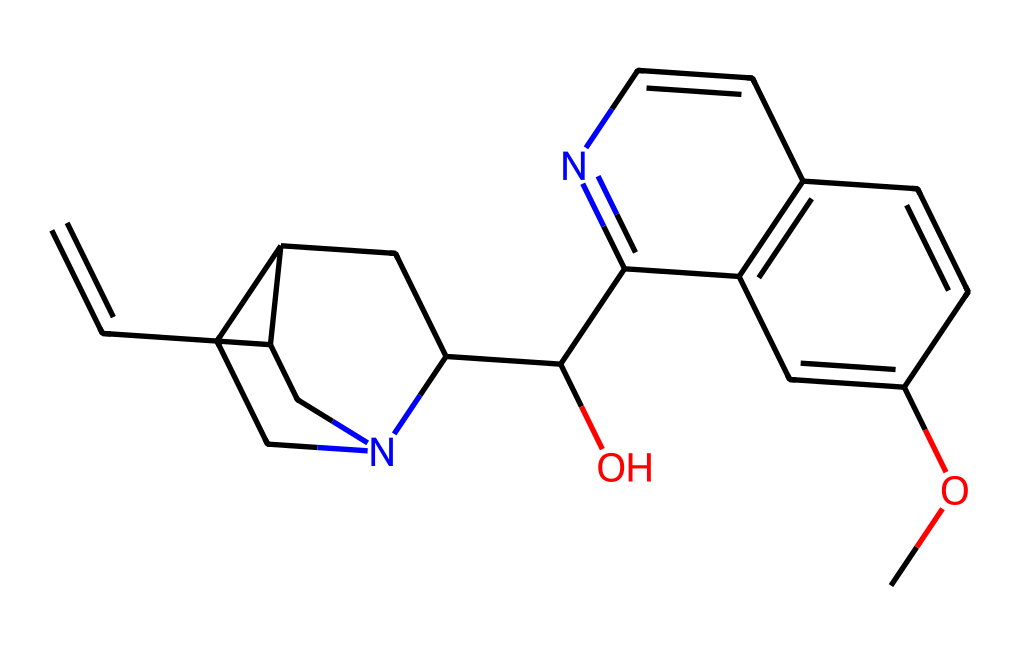What is the chemical name of the structure represented by the SMILES? The SMILES representation corresponds to quinine, which is a well-known antimalarial alkaloid. The specific arrangement of atoms and bonds indicates that it is quinine.
Answer: quinine How many nitrogen atoms are present in this structure? By examining the SMILES representation, we identify and count the nitrogen atoms, which appear to be two in total.
Answer: two What functional group is represented within this alkaloid? The chemical structure includes an ether functional group, as indicated by the "-O-" or oxygen atom connected to carbon chains.
Answer: ether What type of carbon chain is primarily found in quinine? An analysis of the structure reveals that quinine contains multiple fused cyclohexane rings, which are typical of its organic structure.
Answer: fused cyclohexane rings How does the arrangement of atoms contribute to the bioactivity of quinine? The specific arrangement and presence of functional groups like the nitrogen atoms create a shape that fits certain biological targets, leading to its antimalarial properties. The diverse ring structure and functional groups enhance its interaction with biological systems.
Answer: it enhances interaction with biological targets What is the significance of the hydroxyl group in quinine? The hydroxyl (-OH) group can affect solubility and can also participate in hydrogen bonding, which is vital for its biological activity and pharmacological effectiveness.
Answer: it affects solubility and bonding How might the structure of quinine influence its pharmacokinetics? The complex structure, including the rings and functional groups, affects absorption, distribution, metabolism, and excretion (ADME) properties of quinine, influencing how it works in the body and how long it lasts.
Answer: it influences ADME properties 